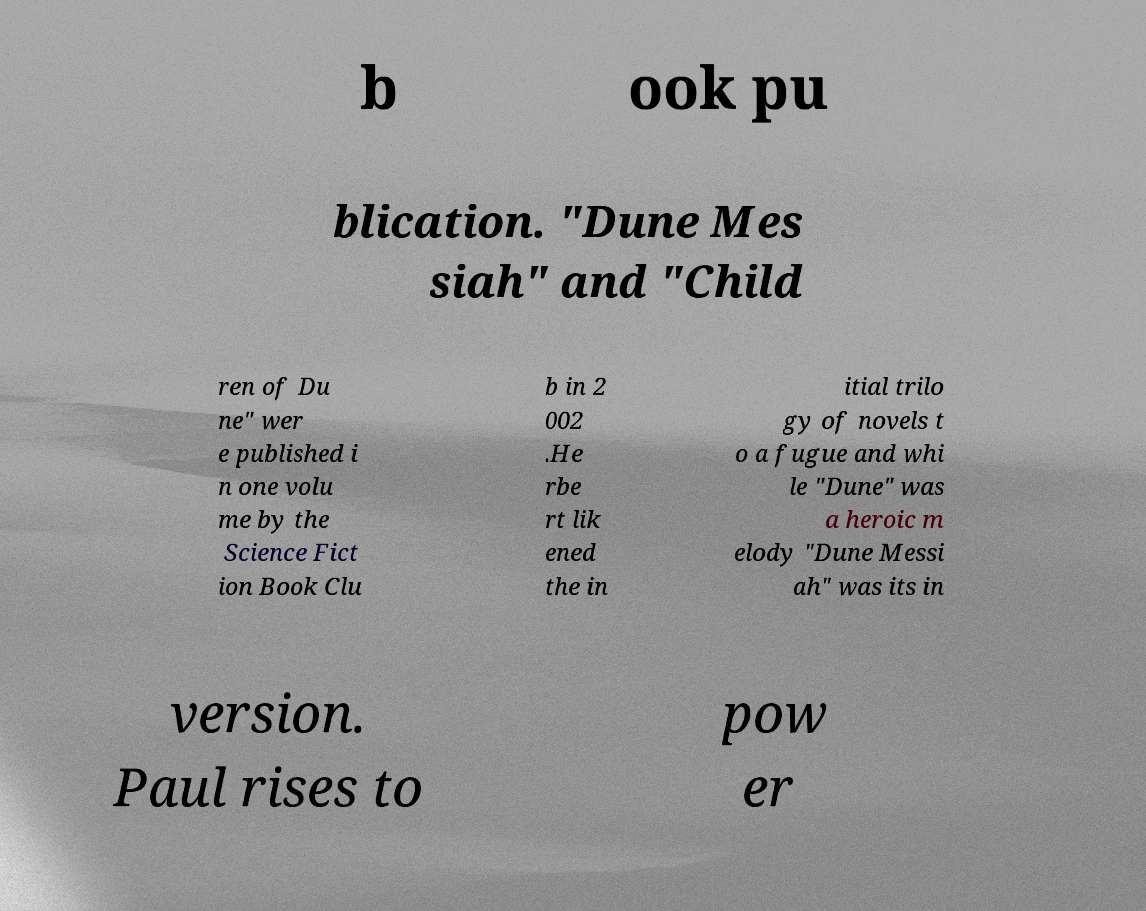There's text embedded in this image that I need extracted. Can you transcribe it verbatim? b ook pu blication. "Dune Mes siah" and "Child ren of Du ne" wer e published i n one volu me by the Science Fict ion Book Clu b in 2 002 .He rbe rt lik ened the in itial trilo gy of novels t o a fugue and whi le "Dune" was a heroic m elody "Dune Messi ah" was its in version. Paul rises to pow er 